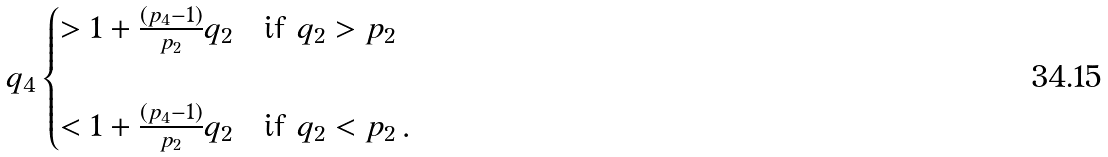Convert formula to latex. <formula><loc_0><loc_0><loc_500><loc_500>q _ { 4 } \begin{cases} > 1 + \frac { ( p _ { 4 } - 1 ) } { p _ { 2 } } q _ { 2 } \quad \text {if $q_{2}>p_{2}$} \\ \\ < 1 + \frac { ( p _ { 4 } - 1 ) } { p _ { 2 } } q _ { 2 } \quad \text {if $q_{2}<p_{2}$} \, . \end{cases}</formula> 